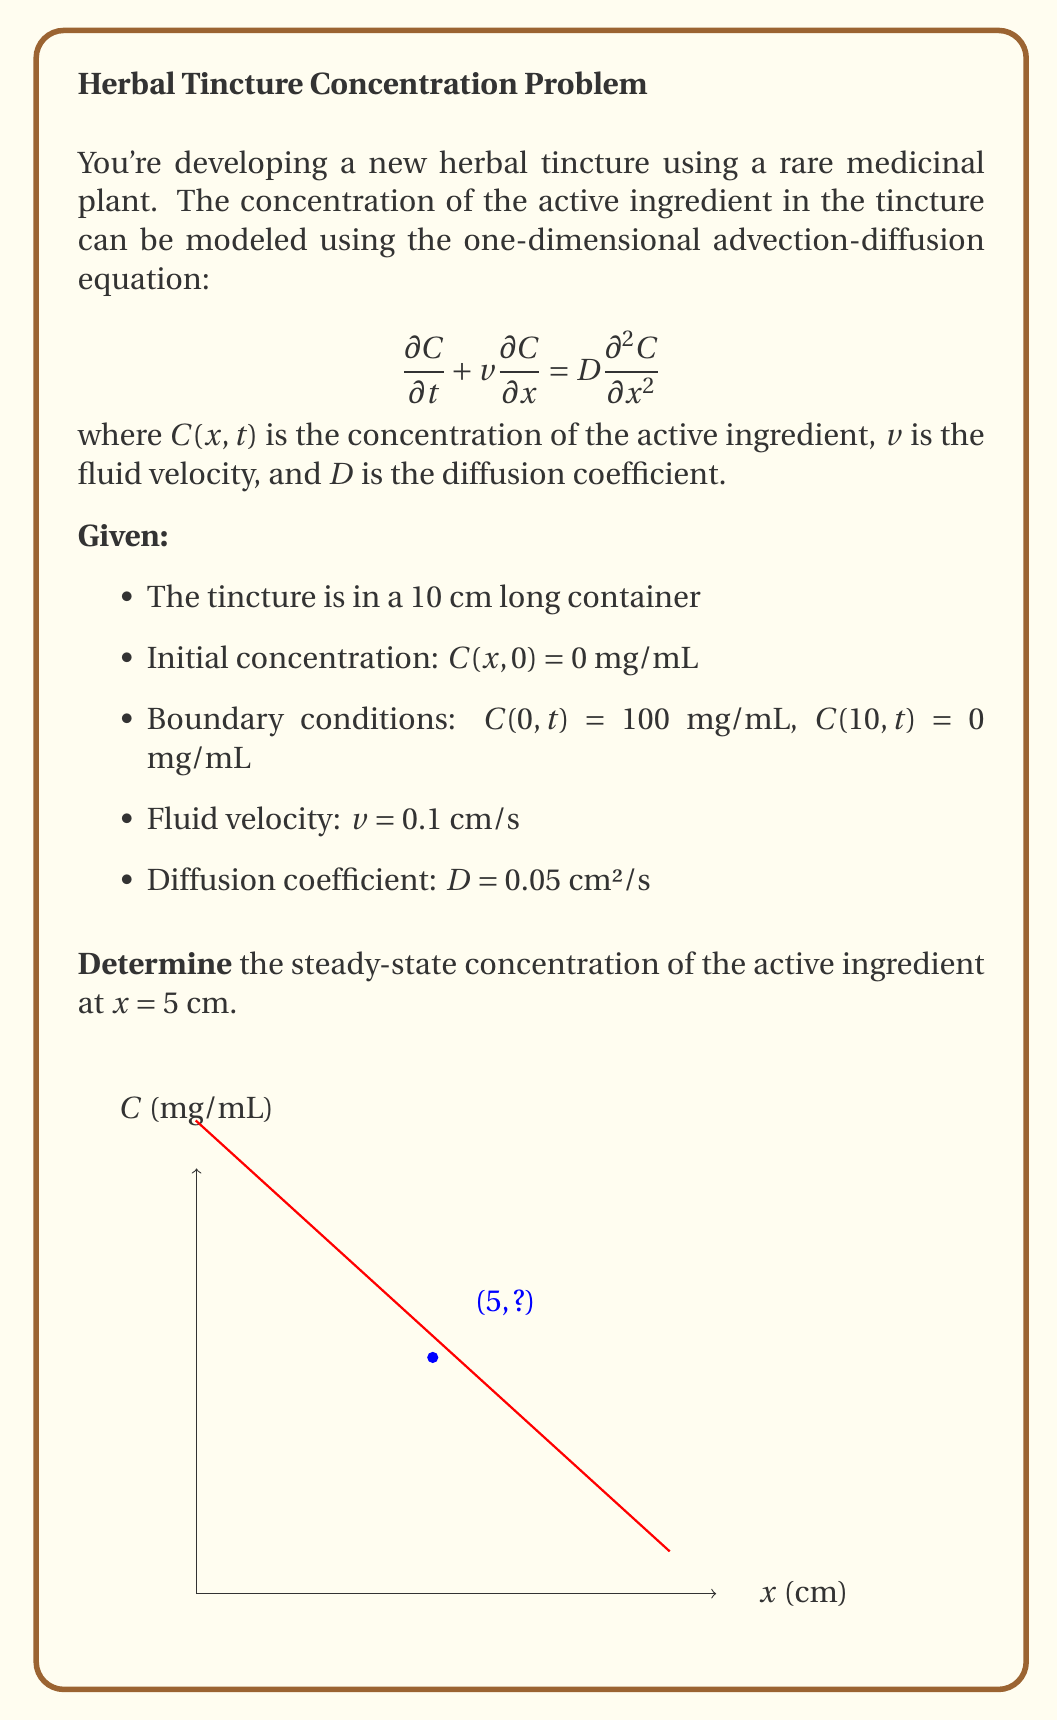Solve this math problem. To solve this problem, we'll follow these steps:

1) For the steady-state solution, we set $\frac{\partial C}{\partial t} = 0$. The equation becomes:

   $$v\frac{dC}{dx} = D\frac{d^2C}{dx^2}$$

2) This is a second-order ODE. We can solve it by integrating twice:

   $$\frac{dC}{dx} = A e^{\frac{v}{D}x}$$
   $$C(x) = \frac{AD}{v}e^{\frac{v}{D}x} + B$$

   where $A$ and $B$ are constants determined by the boundary conditions.

3) Apply the boundary conditions:

   At $x = 0$: $C(0) = \frac{AD}{v} + B = 100$
   At $x = 10$: $C(10) = \frac{AD}{v}e^{\frac{10v}{D}} + B = 0$

4) Solve this system of equations:

   $B = 100 - \frac{AD}{v}$
   $\frac{AD}{v}e^{\frac{10v}{D}} + 100 - \frac{AD}{v} = 0$

5) Simplify and solve for $A$:

   $\frac{AD}{v}(e^{\frac{10v}{D}} - 1) = 100$
   $A = \frac{100v}{D(e^{\frac{10v}{D}} - 1)}$

6) Substitute the values:

   $v = 0.1$ cm/s, $D = 0.05$ cm²/s

   $A = \frac{100 \cdot 0.1}{0.05(e^{\frac{10 \cdot 0.1}{0.05}} - 1)} = -5.0075$

7) The general solution is:

   $$C(x) = 100 - 100\frac{e^{2x} - 1}{e^{20} - 1}$$

8) Evaluate at $x = 5$ cm:

   $$C(5) = 100 - 100\frac{e^{10} - 1}{e^{20} - 1} = 36.79$$ mg/mL
Answer: 36.79 mg/mL 